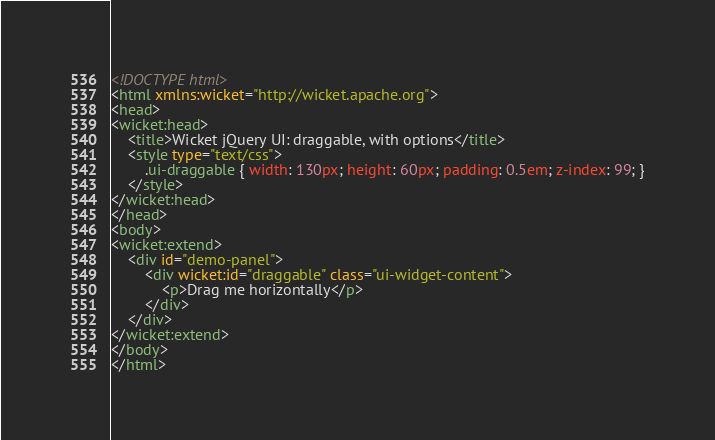<code> <loc_0><loc_0><loc_500><loc_500><_HTML_><!DOCTYPE html>
<html xmlns:wicket="http://wicket.apache.org">
<head>
<wicket:head>
	<title>Wicket jQuery UI: draggable, with options</title>
	<style type="text/css">
		.ui-draggable { width: 130px; height: 60px; padding: 0.5em; z-index: 99; }
	</style>
</wicket:head>
</head>
<body>
<wicket:extend>
	<div id="demo-panel">
		<div wicket:id="draggable" class="ui-widget-content">
			<p>Drag me horizontally</p>
		</div>
	</div>
</wicket:extend>
</body>
</html>
</code> 